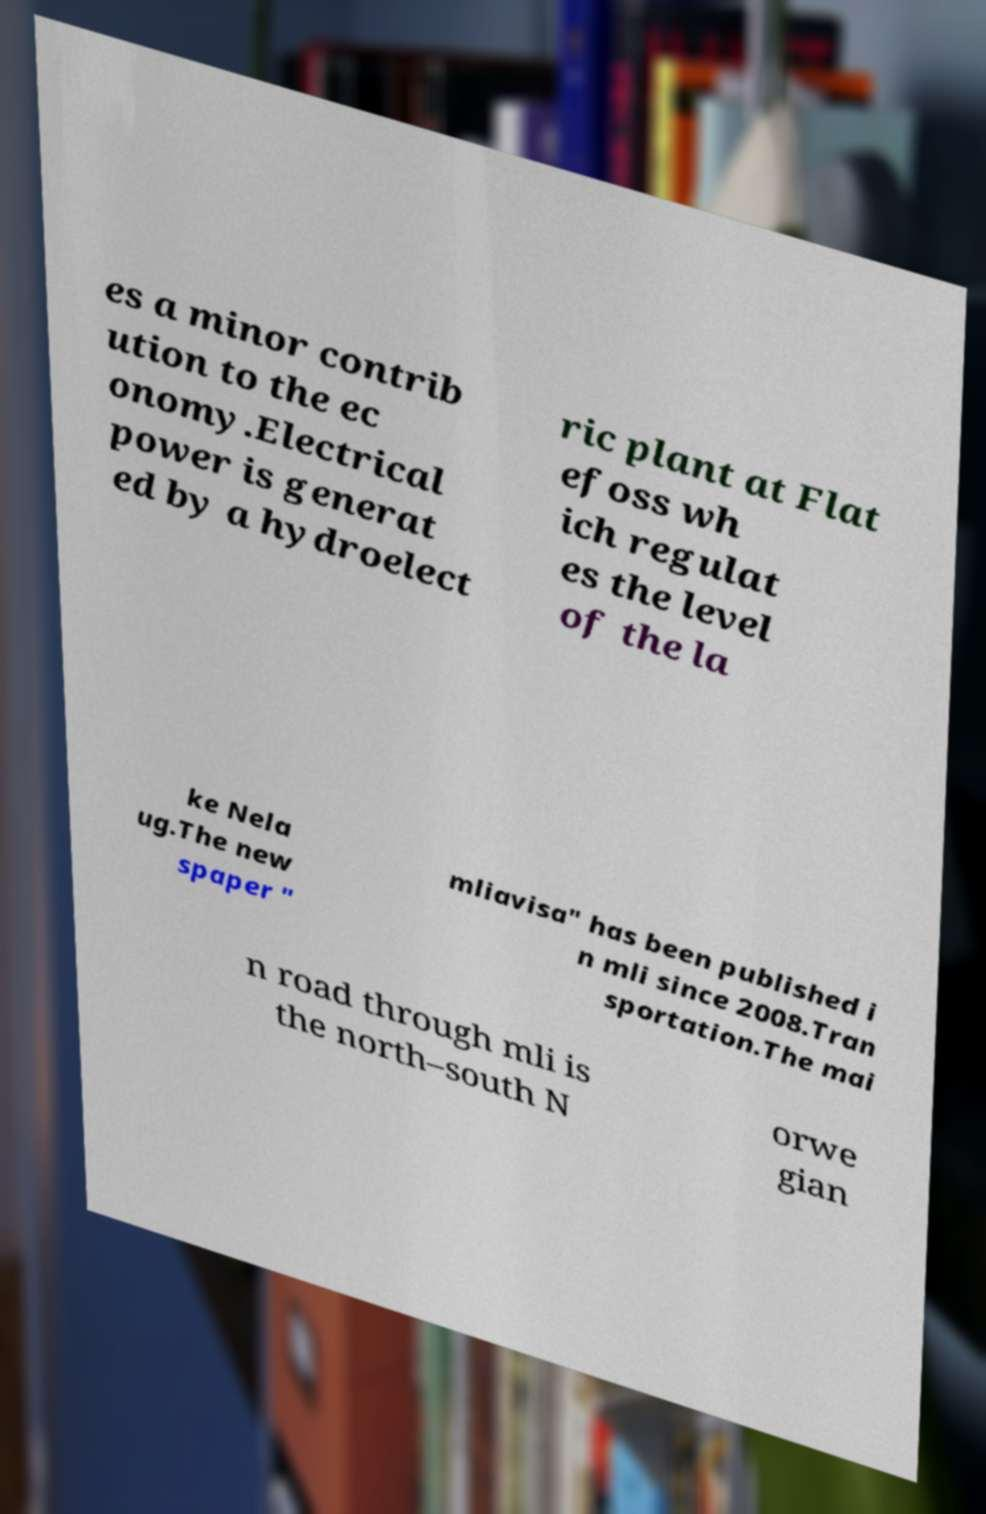Could you assist in decoding the text presented in this image and type it out clearly? es a minor contrib ution to the ec onomy.Electrical power is generat ed by a hydroelect ric plant at Flat efoss wh ich regulat es the level of the la ke Nela ug.The new spaper " mliavisa" has been published i n mli since 2008.Tran sportation.The mai n road through mli is the north–south N orwe gian 